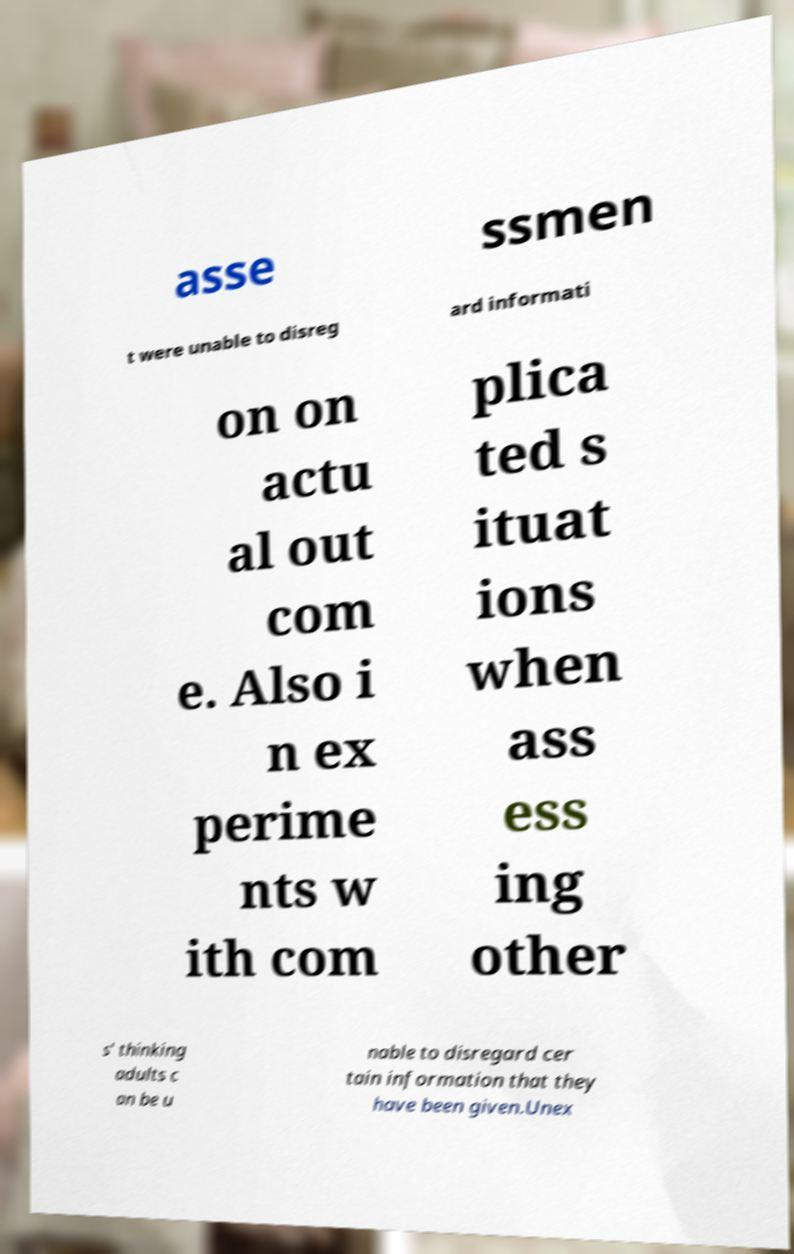There's text embedded in this image that I need extracted. Can you transcribe it verbatim? asse ssmen t were unable to disreg ard informati on on actu al out com e. Also i n ex perime nts w ith com plica ted s ituat ions when ass ess ing other s' thinking adults c an be u nable to disregard cer tain information that they have been given.Unex 